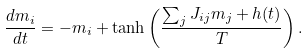Convert formula to latex. <formula><loc_0><loc_0><loc_500><loc_500>\frac { d m _ { i } } { d t } = - m _ { i } + \tanh \left ( \frac { \sum _ { j } J _ { i j } m _ { j } + h ( t ) } { T } \right ) .</formula> 